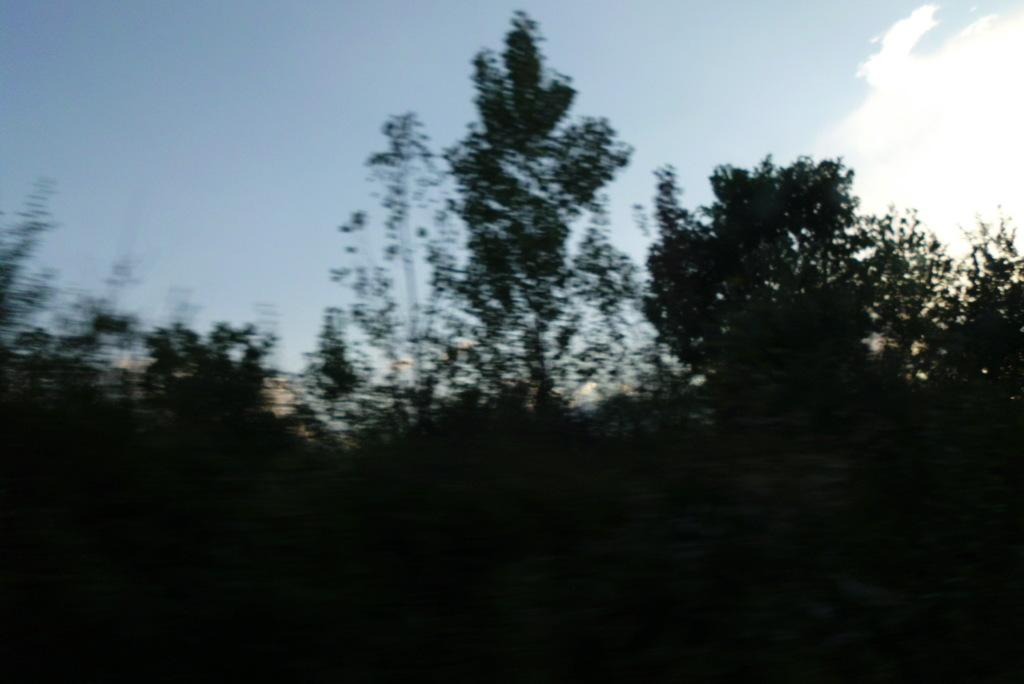What can be seen at the top of the image? The sky is visible in the image. What type of vegetation is present in the image? There are trees in the image. How many boats are visible in the image? There are no boats present in the image. What type of fold can be seen in the trees in the image? There is no fold present in the trees in the image, as trees do not have the ability to fold. 